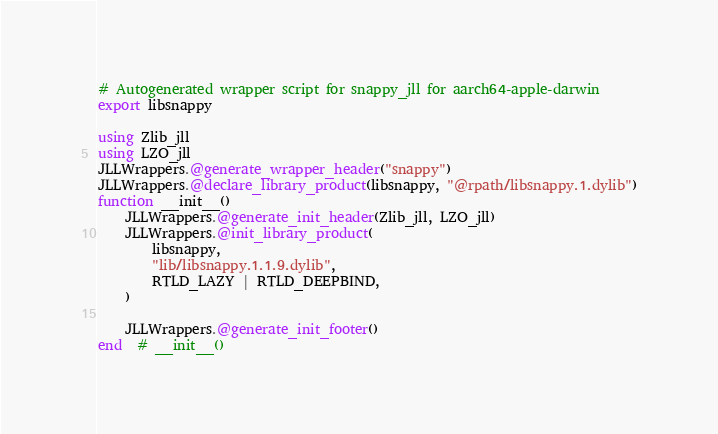Convert code to text. <code><loc_0><loc_0><loc_500><loc_500><_Julia_># Autogenerated wrapper script for snappy_jll for aarch64-apple-darwin
export libsnappy

using Zlib_jll
using LZO_jll
JLLWrappers.@generate_wrapper_header("snappy")
JLLWrappers.@declare_library_product(libsnappy, "@rpath/libsnappy.1.dylib")
function __init__()
    JLLWrappers.@generate_init_header(Zlib_jll, LZO_jll)
    JLLWrappers.@init_library_product(
        libsnappy,
        "lib/libsnappy.1.1.9.dylib",
        RTLD_LAZY | RTLD_DEEPBIND,
    )

    JLLWrappers.@generate_init_footer()
end  # __init__()
</code> 